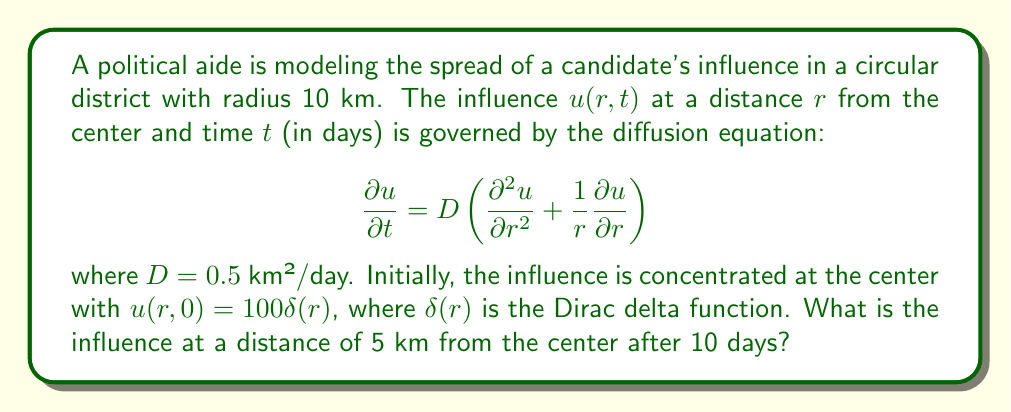Can you answer this question? To solve this problem, we need to use the fundamental solution of the 2D radially symmetric diffusion equation:

1) The solution for the given initial condition is:

   $$u(r,t) = \frac{100}{4\pi Dt} e^{-\frac{r^2}{4Dt}}$$

2) We are given:
   - $D = 0.5$ km²/day
   - $r = 5$ km
   - $t = 10$ days

3) Substituting these values into the equation:

   $$u(5,10) = \frac{100}{4\pi (0.5)(10)} e^{-\frac{5^2}{4(0.5)(10)}}$$

4) Simplify:
   $$u(5,10) = \frac{100}{20\pi} e^{-\frac{25}{20}}$$

5) Calculate:
   $$u(5,10) \approx 0.3183$$

Therefore, the influence at a distance of 5 km from the center after 10 days is approximately 0.3183.
Answer: 0.3183 